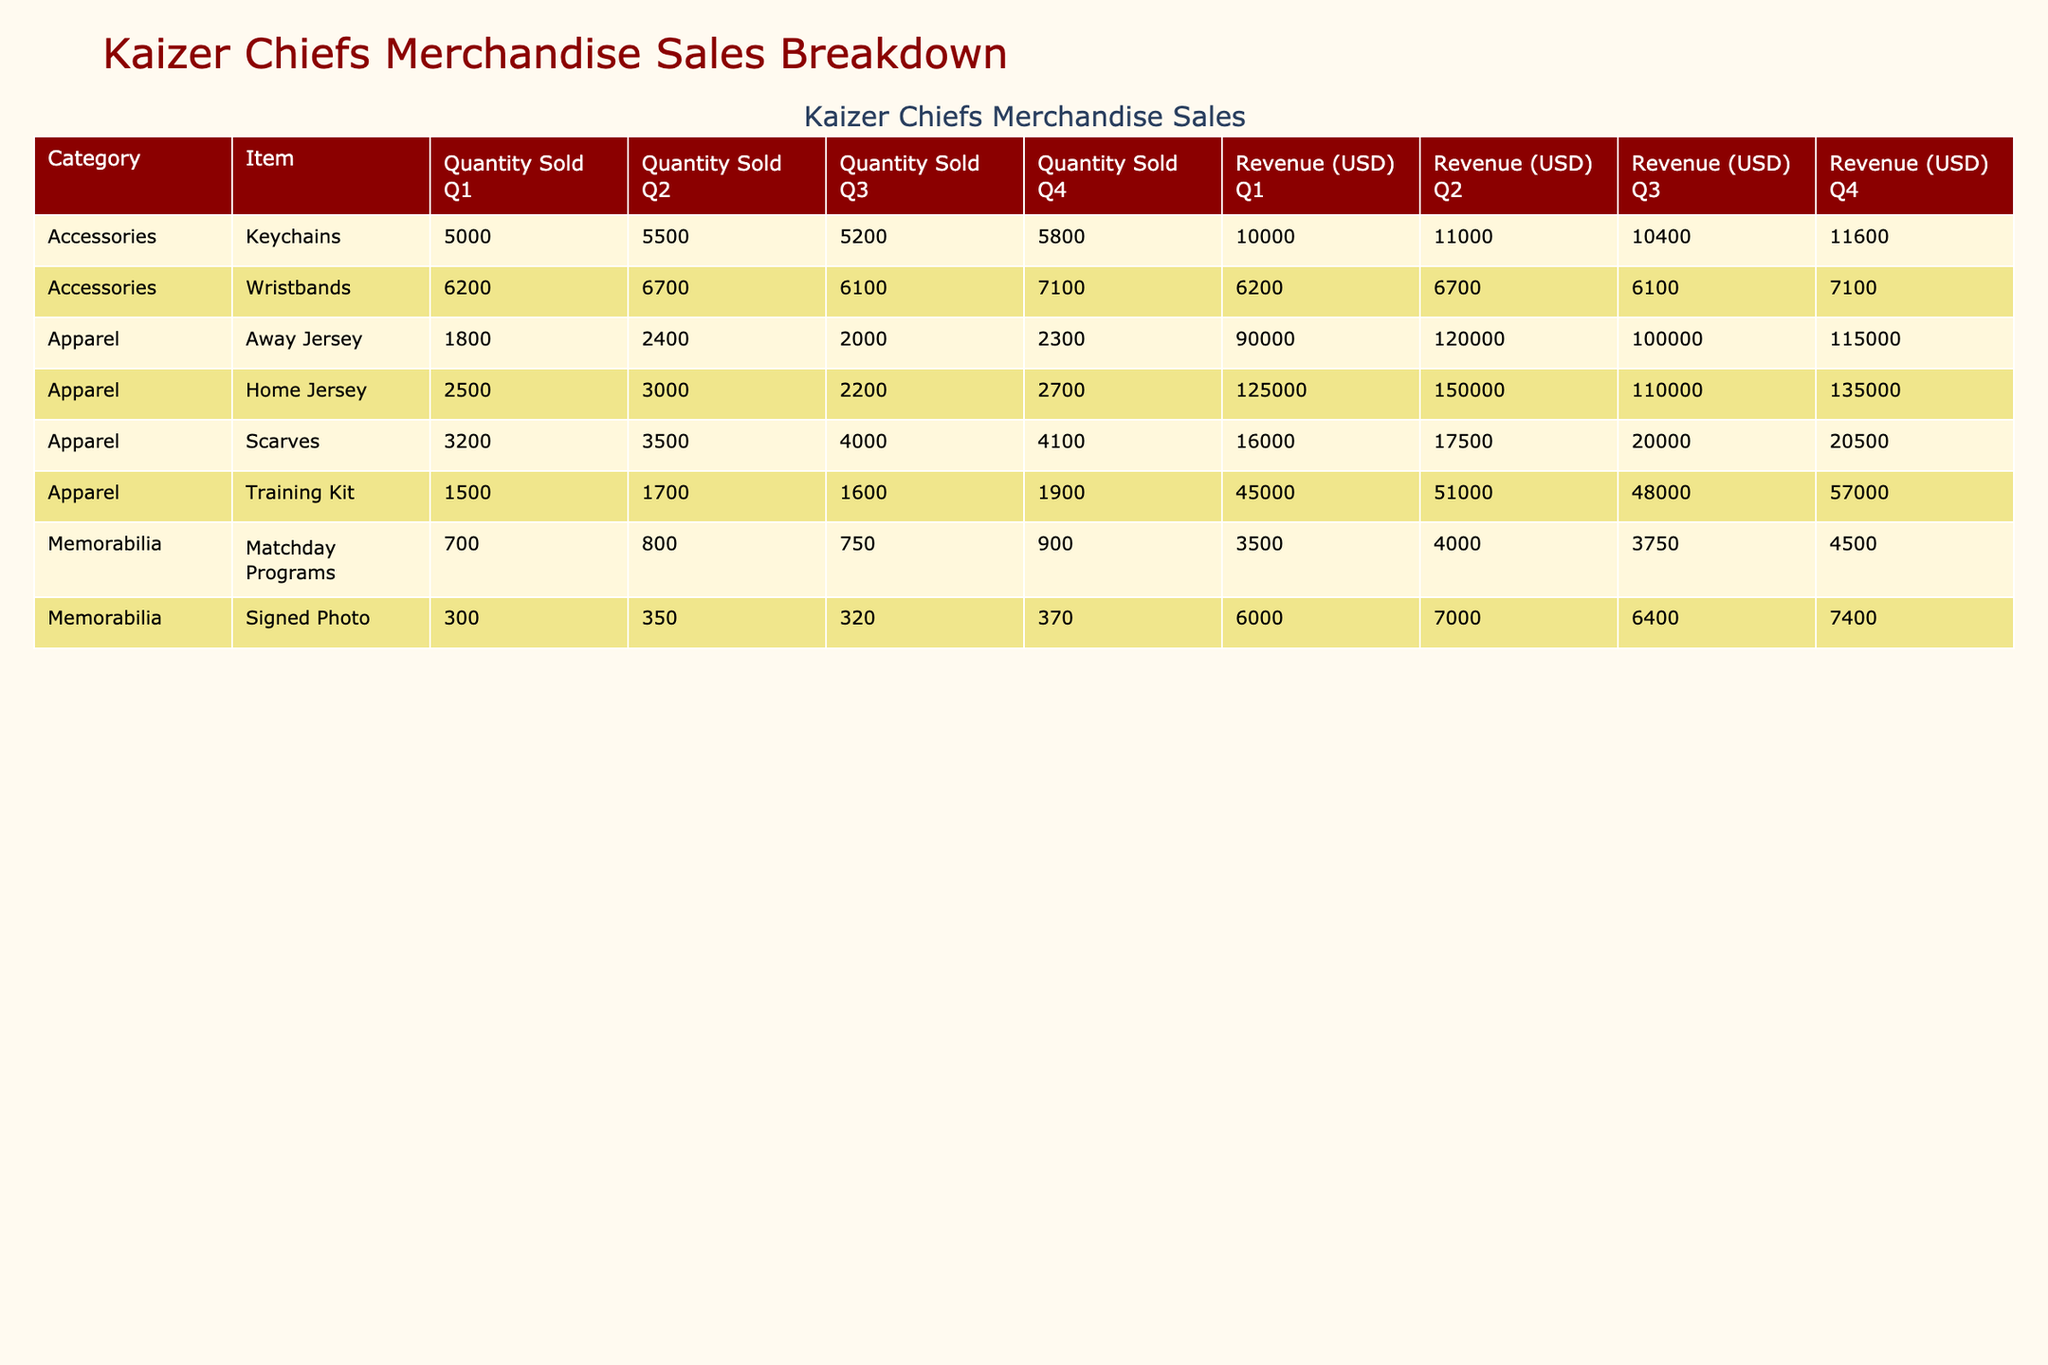What was the total revenue from home jerseys in Q1? In Q1, the revenue from home jerseys is listed as 125000 USD.
Answer: 125000 USD Which quarter had the highest quantity of scarves sold? Looking at the quantities sold for scarves, Q4 shows 4100 units sold, which is higher than Q1 (3200), Q2 (3500), and Q3 (4000).
Answer: Q4 What is the average quantity sold of away jerseys over all quarters? The quantities sold for away jerseys are: Q1 (1800), Q2 (2400), Q3 (2000), and Q4 (2300). The sum is 1800 + 2400 + 2000 + 2300 = 8500. Dividing by 4 gives an average of 8500 / 4 = 2125.
Answer: 2125 Did the sales of keychains increase or decrease from Q1 to Q4? In Q1, keychain sales were 5000, while in Q4, they were 5800. Since 5800 is greater than 5000, it indicates an increase in sales.
Answer: Yes What is the total revenue generated from all apparel items in Q3? The apparel items and their revenues in Q3 are: Home Jersey (110000), Away Jersey (100000), Training Kit (48000), and Scarves (20000). Adding these gives 110000 + 100000 + 48000 + 20000 = 278000.
Answer: 278000 Which category had the highest revenue in Q2? In Q2, the revenues are: Apparel (150000 + 120000 + 51000 + 17500 = 397500), Accessories (11000 + 6700 = 17700), and Memorabilia (4000 + 7000 = 11000). The apparel category had the highest revenue at 397500.
Answer: Apparel What was the percentage increase in the revenue from training kits from Q1 to Q4? The revenue for training kits in Q1 is 45000 and in Q4 is 57000. The increase is 57000 - 45000 = 12000. The percentage increase is (12000 / 45000) * 100, which equals approximately 26.67%.
Answer: 26.67% How many total units of memorabilia (Matchday Programs and Signed Photos) were sold in Q3? For Q3, Matchday Programs sold 750 and Signed Photos sold 320. Adding these together gives 750 + 320 = 1070 units sold in total.
Answer: 1070 